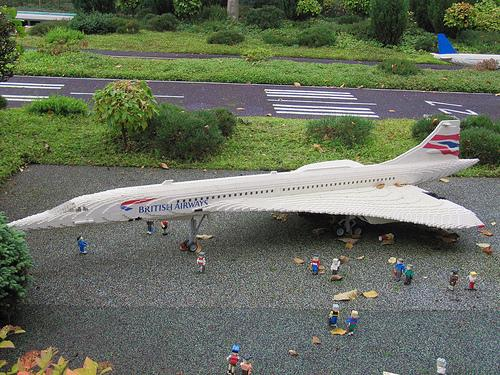Briefly explain what the focal point of the image is and any background elements. A Lego Concorde airplane sits in the foreground with a blue British Airways logo, while green bushes and a tree can be seen in the background. Provide a poetic description of the image's main subject and setting. While watchers gather near and stand. Narrate a concise account of the most notable elements in the image. This British Airways Lego plane features a cockpit, wings, red and blue tail, and front landing gear, surrounded by Lego people watching on a model runway. Describe the image using an informal conversational style. Check out this cool Lego Concorde airplane! It's got the British Airways logo, some Lego people hanging around, and there's even some greenery going on behind it! Mention the main subject of the image and its surroundings in a simple way. There's a Lego British Airways plane with Lego people around it, and it's near some green bushes and a tree. Use a descriptive narrative tone to write about the main object of the image. In the soft glow of a make-believe world, a Lego Concorde airplane bearing the proud insignia of British Airways awaits its next adventure, surrounded by tiny spectators and quirks of nature. Create a vivid description of the primary object in the image. A long and white Lego Concorde airplane stands majestically on a make-believe runway, adorned with blue logos and British Airways insignias. Portray the primary object in the image using an enthusiastic, lively tone. Behold this amazing Lego Concorde airplane! The British Airways logo shines brightly as the plane sits proudly among LEGO people and a vibrant, green backdrop. Summarize the components of the image in one concise sentence. A Lego British Airways plane is surrounded by Lego figures and scenery, including trees and a runway with lines. Describe what's happening in the image as if explaining it to a child. There's a big Lego airplane on a pretend runway, and it has the British Airways logo! Look at all the tiny Lego people watching and the trees and bushes around it. 